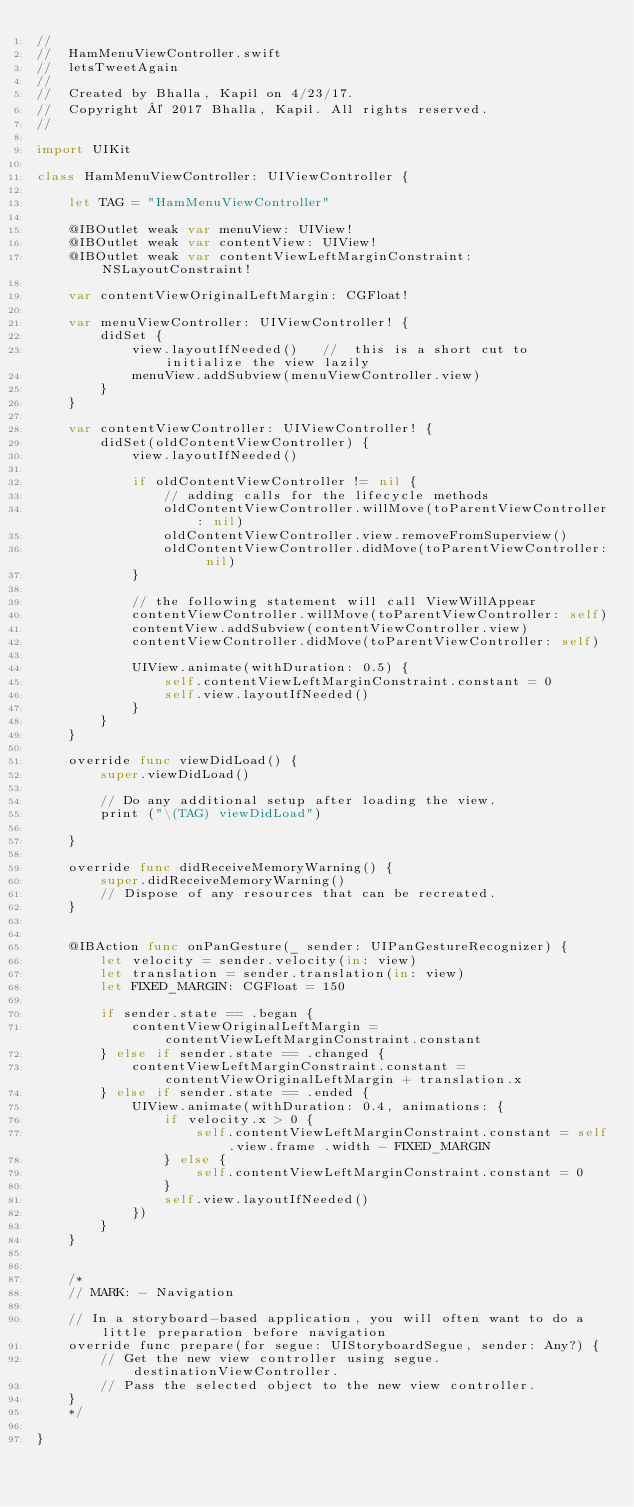<code> <loc_0><loc_0><loc_500><loc_500><_Swift_>//
//  HamMenuViewController.swift
//  letsTweetAgain
//
//  Created by Bhalla, Kapil on 4/23/17.
//  Copyright © 2017 Bhalla, Kapil. All rights reserved.
//

import UIKit

class HamMenuViewController: UIViewController {

    let TAG = "HamMenuViewController"
    
    @IBOutlet weak var menuView: UIView!
    @IBOutlet weak var contentView: UIView!
    @IBOutlet weak var contentViewLeftMarginConstraint: NSLayoutConstraint!
    
    var contentViewOriginalLeftMargin: CGFloat!
    
    var menuViewController: UIViewController! {
        didSet {
            view.layoutIfNeeded()   //  this is a short cut to initialize the view lazily
            menuView.addSubview(menuViewController.view)
        }
    }

    var contentViewController: UIViewController! {
        didSet(oldContentViewController) {
            view.layoutIfNeeded()
            
            if oldContentViewController != nil {
                // adding calls for the lifecycle methods
                oldContentViewController.willMove(toParentViewController: nil)
                oldContentViewController.view.removeFromSuperview()
                oldContentViewController.didMove(toParentViewController: nil)
            }
            
            // the following statement will call ViewWillAppear
            contentViewController.willMove(toParentViewController: self)
            contentView.addSubview(contentViewController.view)
            contentViewController.didMove(toParentViewController: self)
            
            UIView.animate(withDuration: 0.5) {
                self.contentViewLeftMarginConstraint.constant = 0
                self.view.layoutIfNeeded()
            }
        }
    }
    
    override func viewDidLoad() {
        super.viewDidLoad()

        // Do any additional setup after loading the view.
        print ("\(TAG) viewDidLoad")
        
    }

    override func didReceiveMemoryWarning() {
        super.didReceiveMemoryWarning()
        // Dispose of any resources that can be recreated.
    }
    
    
    @IBAction func onPanGesture(_ sender: UIPanGestureRecognizer) {
        let velocity = sender.velocity(in: view)
        let translation = sender.translation(in: view)
        let FIXED_MARGIN: CGFloat = 150
        
        if sender.state == .began {
            contentViewOriginalLeftMargin = contentViewLeftMarginConstraint.constant
        } else if sender.state == .changed {
            contentViewLeftMarginConstraint.constant = contentViewOriginalLeftMargin + translation.x
        } else if sender.state == .ended {
            UIView.animate(withDuration: 0.4, animations: {
                if velocity.x > 0 {
                    self.contentViewLeftMarginConstraint.constant = self.view.frame .width - FIXED_MARGIN
                } else {
                    self.contentViewLeftMarginConstraint.constant = 0
                }
                self.view.layoutIfNeeded()
            })
        }
    }
    

    /*
    // MARK: - Navigation

    // In a storyboard-based application, you will often want to do a little preparation before navigation
    override func prepare(for segue: UIStoryboardSegue, sender: Any?) {
        // Get the new view controller using segue.destinationViewController.
        // Pass the selected object to the new view controller.
    }
    */

}
</code> 